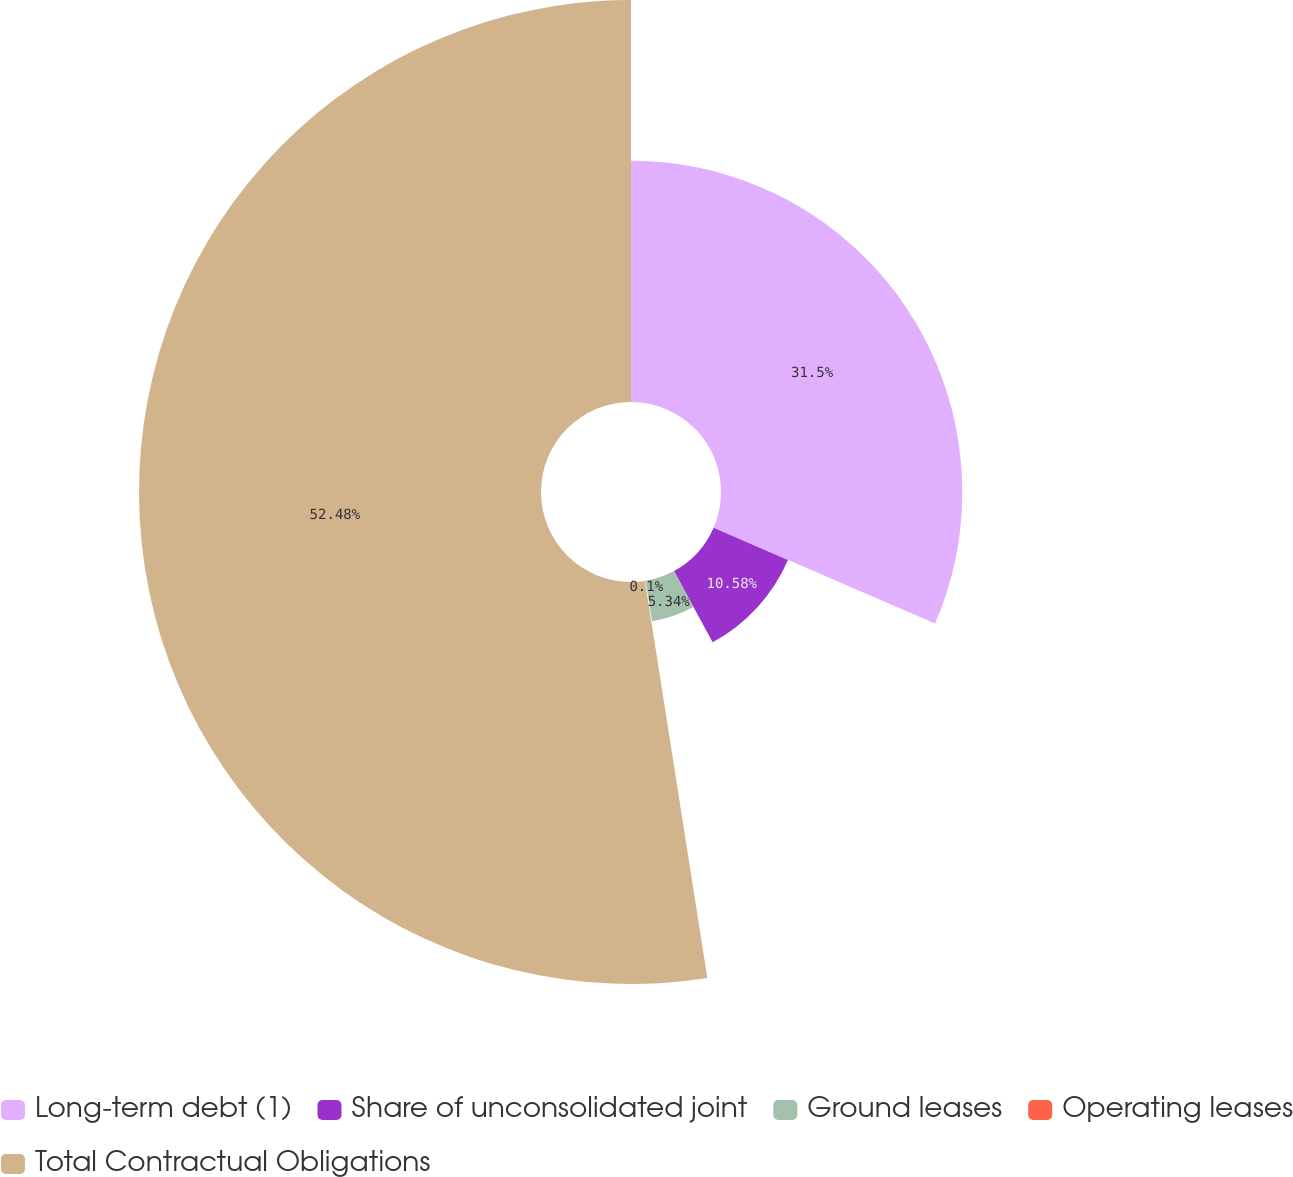<chart> <loc_0><loc_0><loc_500><loc_500><pie_chart><fcel>Long-term debt (1)<fcel>Share of unconsolidated joint<fcel>Ground leases<fcel>Operating leases<fcel>Total Contractual Obligations<nl><fcel>31.5%<fcel>10.58%<fcel>5.34%<fcel>0.1%<fcel>52.48%<nl></chart> 